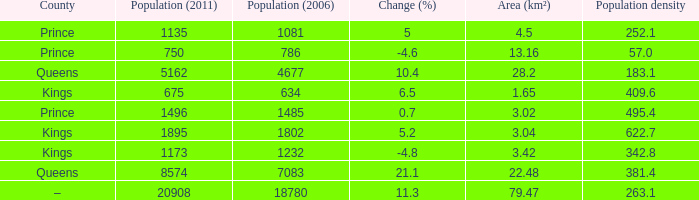02, and the population (2006) surpassed 786, and the population (2011) was below 1135? None. 